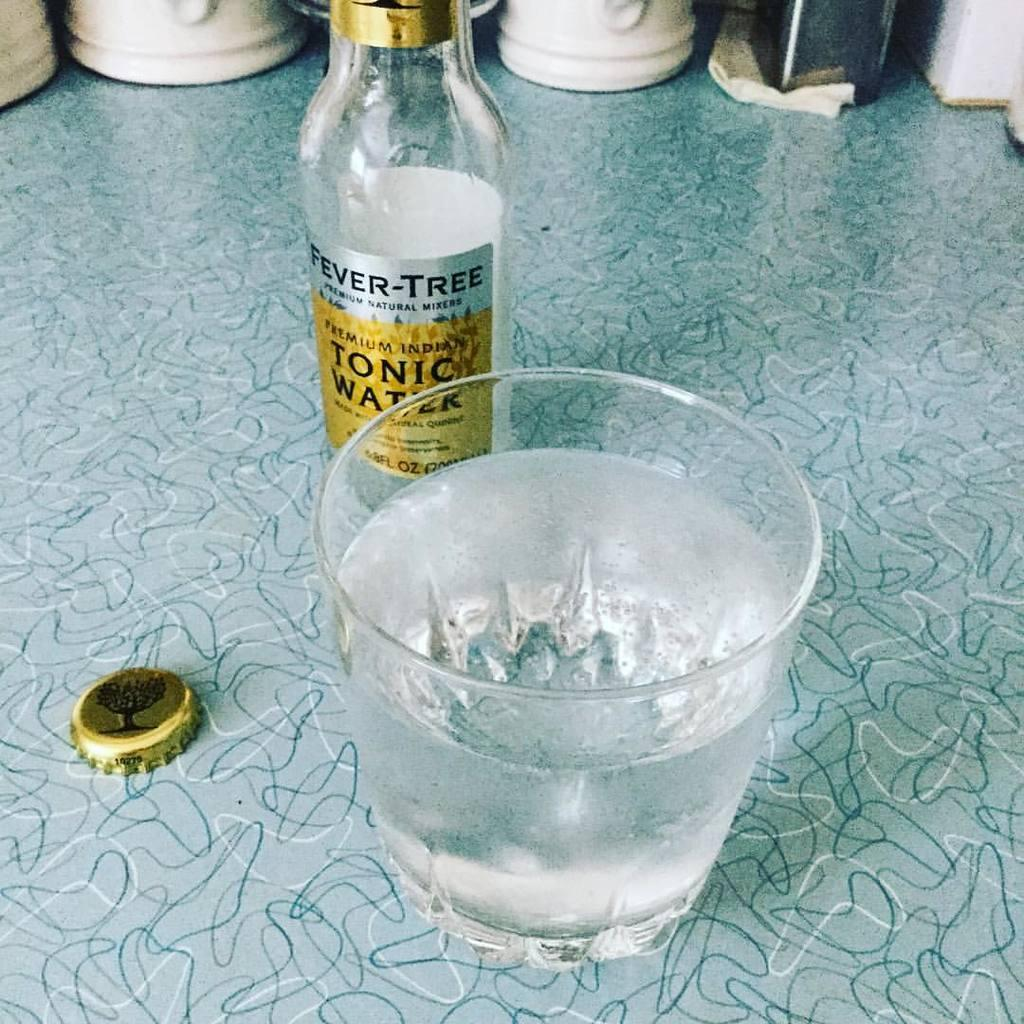<image>
Write a terse but informative summary of the picture. a bottle of fever-tree tonic water behind a glass of water 